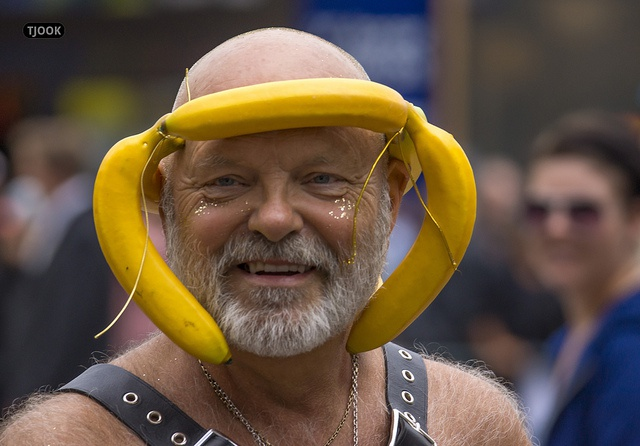Describe the objects in this image and their specific colors. I can see people in black, maroon, and gray tones, people in black, gray, navy, and maroon tones, people in black and gray tones, banana in black, orange, and olive tones, and banana in black, olive, and orange tones in this image. 